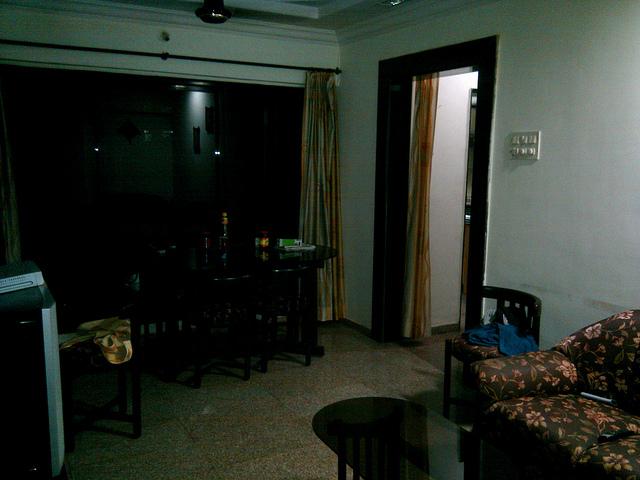How many chairs?
Be succinct. 2. Does the table have a bench?
Short answer required. No. Is the coffee table reflective?
Be succinct. Yes. Is there a TV in the picture?
Be succinct. Yes. Is this a flat-screen TV?
Short answer required. No. Is the room decorated all in red?
Short answer required. No. Is the door closed?
Short answer required. No. What is the floor made of?
Short answer required. Carpet. 